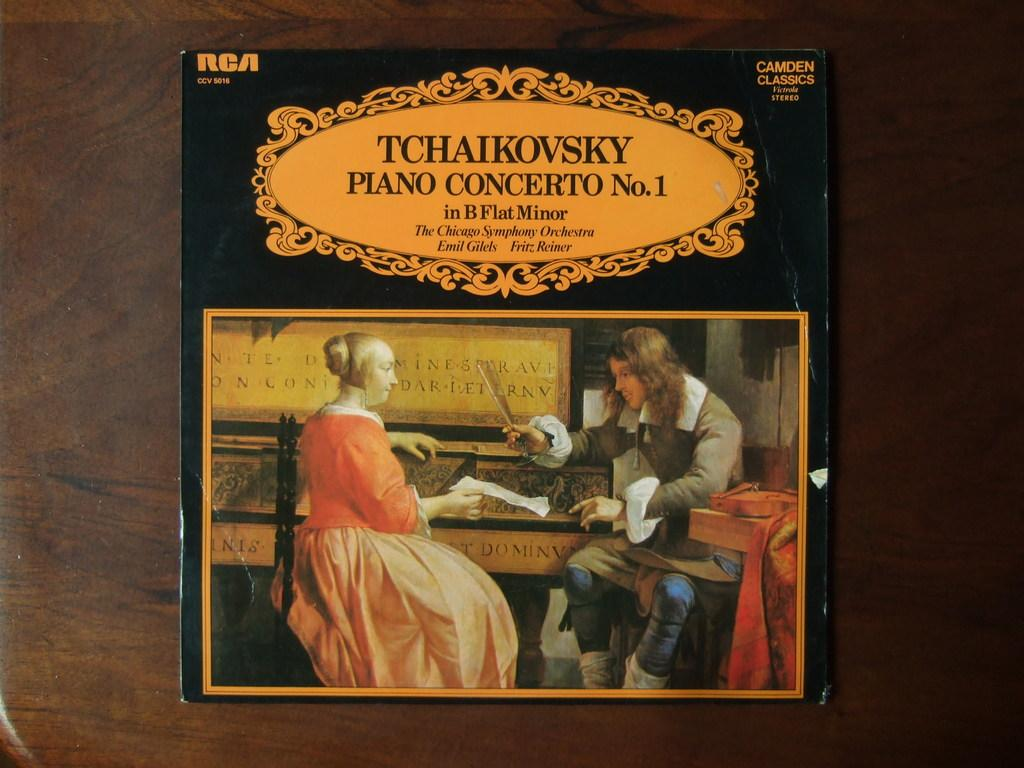<image>
Share a concise interpretation of the image provided. Album cover for Tchaikovsky showing a man teaching a woman something. 